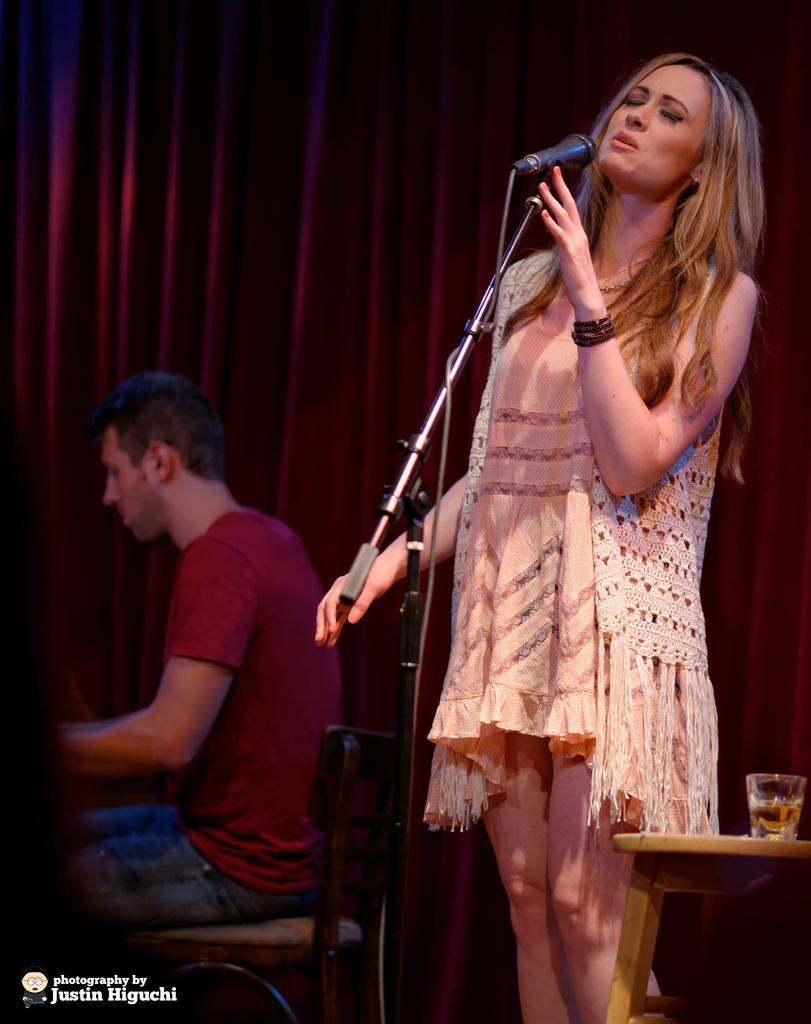Describe this image in one or two sentences. In this picture, we see a woman is standing. In front of her, we see a microphone stand. I think she is singing the song on the microphone. In the right bottom, we see a stool on which a glass containing the liquid is placed. On the left side, we see a man in the maroon T-shirt is sitting on the chair. In the background, we see a curtain or a sheet in maroon color. 